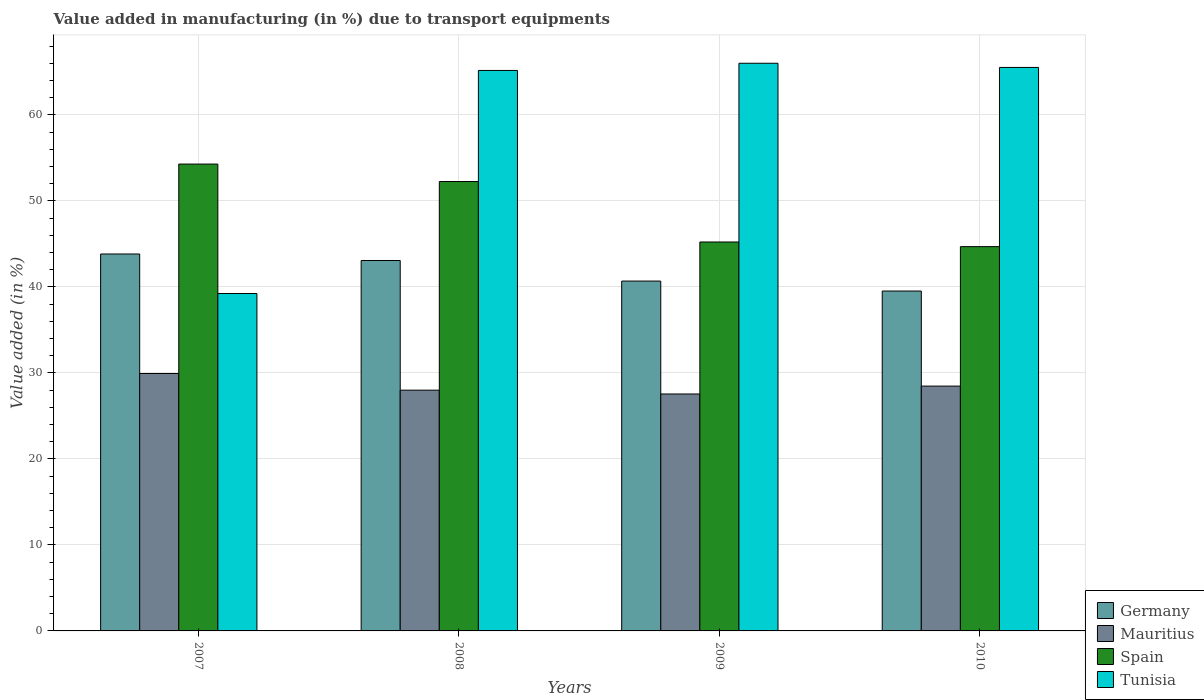How many different coloured bars are there?
Keep it short and to the point. 4. How many groups of bars are there?
Keep it short and to the point. 4. Are the number of bars per tick equal to the number of legend labels?
Your response must be concise. Yes. How many bars are there on the 3rd tick from the left?
Provide a succinct answer. 4. What is the percentage of value added in manufacturing due to transport equipments in Spain in 2009?
Provide a short and direct response. 45.22. Across all years, what is the maximum percentage of value added in manufacturing due to transport equipments in Tunisia?
Make the answer very short. 66. Across all years, what is the minimum percentage of value added in manufacturing due to transport equipments in Spain?
Your answer should be very brief. 44.68. In which year was the percentage of value added in manufacturing due to transport equipments in Mauritius maximum?
Keep it short and to the point. 2007. What is the total percentage of value added in manufacturing due to transport equipments in Mauritius in the graph?
Offer a very short reply. 113.93. What is the difference between the percentage of value added in manufacturing due to transport equipments in Germany in 2008 and that in 2009?
Make the answer very short. 2.39. What is the difference between the percentage of value added in manufacturing due to transport equipments in Tunisia in 2010 and the percentage of value added in manufacturing due to transport equipments in Mauritius in 2009?
Your answer should be very brief. 37.96. What is the average percentage of value added in manufacturing due to transport equipments in Germany per year?
Offer a terse response. 41.77. In the year 2008, what is the difference between the percentage of value added in manufacturing due to transport equipments in Germany and percentage of value added in manufacturing due to transport equipments in Mauritius?
Provide a succinct answer. 15.08. What is the ratio of the percentage of value added in manufacturing due to transport equipments in Spain in 2008 to that in 2009?
Your answer should be compact. 1.16. What is the difference between the highest and the second highest percentage of value added in manufacturing due to transport equipments in Germany?
Provide a short and direct response. 0.75. What is the difference between the highest and the lowest percentage of value added in manufacturing due to transport equipments in Spain?
Give a very brief answer. 9.6. Is it the case that in every year, the sum of the percentage of value added in manufacturing due to transport equipments in Mauritius and percentage of value added in manufacturing due to transport equipments in Tunisia is greater than the sum of percentage of value added in manufacturing due to transport equipments in Germany and percentage of value added in manufacturing due to transport equipments in Spain?
Your response must be concise. Yes. What does the 1st bar from the left in 2010 represents?
Provide a short and direct response. Germany. What does the 2nd bar from the right in 2008 represents?
Your answer should be compact. Spain. Is it the case that in every year, the sum of the percentage of value added in manufacturing due to transport equipments in Spain and percentage of value added in manufacturing due to transport equipments in Germany is greater than the percentage of value added in manufacturing due to transport equipments in Tunisia?
Your response must be concise. Yes. How many bars are there?
Provide a succinct answer. 16. How many years are there in the graph?
Provide a succinct answer. 4. What is the difference between two consecutive major ticks on the Y-axis?
Give a very brief answer. 10. Does the graph contain grids?
Provide a short and direct response. Yes. Where does the legend appear in the graph?
Ensure brevity in your answer.  Bottom right. How many legend labels are there?
Make the answer very short. 4. How are the legend labels stacked?
Provide a succinct answer. Vertical. What is the title of the graph?
Give a very brief answer. Value added in manufacturing (in %) due to transport equipments. What is the label or title of the Y-axis?
Offer a terse response. Value added (in %). What is the Value added (in %) of Germany in 2007?
Your answer should be very brief. 43.82. What is the Value added (in %) of Mauritius in 2007?
Your response must be concise. 29.93. What is the Value added (in %) of Spain in 2007?
Offer a very short reply. 54.28. What is the Value added (in %) of Tunisia in 2007?
Keep it short and to the point. 39.23. What is the Value added (in %) of Germany in 2008?
Your response must be concise. 43.07. What is the Value added (in %) in Mauritius in 2008?
Your answer should be very brief. 27.99. What is the Value added (in %) in Spain in 2008?
Ensure brevity in your answer.  52.24. What is the Value added (in %) of Tunisia in 2008?
Give a very brief answer. 65.16. What is the Value added (in %) in Germany in 2009?
Ensure brevity in your answer.  40.67. What is the Value added (in %) of Mauritius in 2009?
Your answer should be compact. 27.55. What is the Value added (in %) in Spain in 2009?
Your answer should be very brief. 45.22. What is the Value added (in %) of Tunisia in 2009?
Offer a terse response. 66. What is the Value added (in %) of Germany in 2010?
Offer a terse response. 39.51. What is the Value added (in %) of Mauritius in 2010?
Your response must be concise. 28.46. What is the Value added (in %) of Spain in 2010?
Keep it short and to the point. 44.68. What is the Value added (in %) of Tunisia in 2010?
Give a very brief answer. 65.51. Across all years, what is the maximum Value added (in %) in Germany?
Your answer should be compact. 43.82. Across all years, what is the maximum Value added (in %) of Mauritius?
Offer a terse response. 29.93. Across all years, what is the maximum Value added (in %) of Spain?
Your answer should be compact. 54.28. Across all years, what is the maximum Value added (in %) in Tunisia?
Your response must be concise. 66. Across all years, what is the minimum Value added (in %) in Germany?
Offer a terse response. 39.51. Across all years, what is the minimum Value added (in %) of Mauritius?
Make the answer very short. 27.55. Across all years, what is the minimum Value added (in %) in Spain?
Your response must be concise. 44.68. Across all years, what is the minimum Value added (in %) in Tunisia?
Provide a short and direct response. 39.23. What is the total Value added (in %) of Germany in the graph?
Keep it short and to the point. 167.08. What is the total Value added (in %) in Mauritius in the graph?
Your answer should be very brief. 113.93. What is the total Value added (in %) of Spain in the graph?
Provide a short and direct response. 196.42. What is the total Value added (in %) in Tunisia in the graph?
Offer a terse response. 235.9. What is the difference between the Value added (in %) of Germany in 2007 and that in 2008?
Make the answer very short. 0.75. What is the difference between the Value added (in %) of Mauritius in 2007 and that in 2008?
Offer a terse response. 1.94. What is the difference between the Value added (in %) of Spain in 2007 and that in 2008?
Your answer should be very brief. 2.03. What is the difference between the Value added (in %) of Tunisia in 2007 and that in 2008?
Your answer should be very brief. -25.93. What is the difference between the Value added (in %) in Germany in 2007 and that in 2009?
Offer a terse response. 3.15. What is the difference between the Value added (in %) of Mauritius in 2007 and that in 2009?
Offer a very short reply. 2.38. What is the difference between the Value added (in %) in Spain in 2007 and that in 2009?
Ensure brevity in your answer.  9.06. What is the difference between the Value added (in %) of Tunisia in 2007 and that in 2009?
Provide a short and direct response. -26.77. What is the difference between the Value added (in %) of Germany in 2007 and that in 2010?
Ensure brevity in your answer.  4.31. What is the difference between the Value added (in %) of Mauritius in 2007 and that in 2010?
Ensure brevity in your answer.  1.46. What is the difference between the Value added (in %) of Spain in 2007 and that in 2010?
Keep it short and to the point. 9.6. What is the difference between the Value added (in %) of Tunisia in 2007 and that in 2010?
Provide a succinct answer. -26.28. What is the difference between the Value added (in %) of Germany in 2008 and that in 2009?
Keep it short and to the point. 2.39. What is the difference between the Value added (in %) of Mauritius in 2008 and that in 2009?
Your response must be concise. 0.44. What is the difference between the Value added (in %) in Spain in 2008 and that in 2009?
Provide a short and direct response. 7.03. What is the difference between the Value added (in %) in Tunisia in 2008 and that in 2009?
Give a very brief answer. -0.83. What is the difference between the Value added (in %) of Germany in 2008 and that in 2010?
Offer a terse response. 3.55. What is the difference between the Value added (in %) in Mauritius in 2008 and that in 2010?
Offer a terse response. -0.47. What is the difference between the Value added (in %) in Spain in 2008 and that in 2010?
Provide a short and direct response. 7.57. What is the difference between the Value added (in %) of Tunisia in 2008 and that in 2010?
Offer a terse response. -0.35. What is the difference between the Value added (in %) of Germany in 2009 and that in 2010?
Ensure brevity in your answer.  1.16. What is the difference between the Value added (in %) in Mauritius in 2009 and that in 2010?
Your answer should be compact. -0.92. What is the difference between the Value added (in %) of Spain in 2009 and that in 2010?
Offer a very short reply. 0.54. What is the difference between the Value added (in %) of Tunisia in 2009 and that in 2010?
Provide a short and direct response. 0.49. What is the difference between the Value added (in %) of Germany in 2007 and the Value added (in %) of Mauritius in 2008?
Your response must be concise. 15.83. What is the difference between the Value added (in %) in Germany in 2007 and the Value added (in %) in Spain in 2008?
Provide a short and direct response. -8.42. What is the difference between the Value added (in %) in Germany in 2007 and the Value added (in %) in Tunisia in 2008?
Make the answer very short. -21.34. What is the difference between the Value added (in %) in Mauritius in 2007 and the Value added (in %) in Spain in 2008?
Offer a very short reply. -22.32. What is the difference between the Value added (in %) of Mauritius in 2007 and the Value added (in %) of Tunisia in 2008?
Make the answer very short. -35.24. What is the difference between the Value added (in %) in Spain in 2007 and the Value added (in %) in Tunisia in 2008?
Make the answer very short. -10.89. What is the difference between the Value added (in %) of Germany in 2007 and the Value added (in %) of Mauritius in 2009?
Your answer should be very brief. 16.27. What is the difference between the Value added (in %) in Germany in 2007 and the Value added (in %) in Spain in 2009?
Your response must be concise. -1.4. What is the difference between the Value added (in %) of Germany in 2007 and the Value added (in %) of Tunisia in 2009?
Offer a terse response. -22.18. What is the difference between the Value added (in %) in Mauritius in 2007 and the Value added (in %) in Spain in 2009?
Offer a very short reply. -15.29. What is the difference between the Value added (in %) in Mauritius in 2007 and the Value added (in %) in Tunisia in 2009?
Your answer should be very brief. -36.07. What is the difference between the Value added (in %) of Spain in 2007 and the Value added (in %) of Tunisia in 2009?
Your answer should be very brief. -11.72. What is the difference between the Value added (in %) in Germany in 2007 and the Value added (in %) in Mauritius in 2010?
Make the answer very short. 15.36. What is the difference between the Value added (in %) in Germany in 2007 and the Value added (in %) in Spain in 2010?
Your answer should be compact. -0.86. What is the difference between the Value added (in %) in Germany in 2007 and the Value added (in %) in Tunisia in 2010?
Your answer should be compact. -21.69. What is the difference between the Value added (in %) of Mauritius in 2007 and the Value added (in %) of Spain in 2010?
Make the answer very short. -14.75. What is the difference between the Value added (in %) in Mauritius in 2007 and the Value added (in %) in Tunisia in 2010?
Your answer should be compact. -35.58. What is the difference between the Value added (in %) of Spain in 2007 and the Value added (in %) of Tunisia in 2010?
Provide a succinct answer. -11.23. What is the difference between the Value added (in %) of Germany in 2008 and the Value added (in %) of Mauritius in 2009?
Your answer should be very brief. 15.52. What is the difference between the Value added (in %) in Germany in 2008 and the Value added (in %) in Spain in 2009?
Give a very brief answer. -2.15. What is the difference between the Value added (in %) of Germany in 2008 and the Value added (in %) of Tunisia in 2009?
Your answer should be very brief. -22.93. What is the difference between the Value added (in %) of Mauritius in 2008 and the Value added (in %) of Spain in 2009?
Keep it short and to the point. -17.23. What is the difference between the Value added (in %) in Mauritius in 2008 and the Value added (in %) in Tunisia in 2009?
Offer a terse response. -38.01. What is the difference between the Value added (in %) of Spain in 2008 and the Value added (in %) of Tunisia in 2009?
Offer a very short reply. -13.75. What is the difference between the Value added (in %) of Germany in 2008 and the Value added (in %) of Mauritius in 2010?
Your response must be concise. 14.6. What is the difference between the Value added (in %) in Germany in 2008 and the Value added (in %) in Spain in 2010?
Offer a very short reply. -1.61. What is the difference between the Value added (in %) in Germany in 2008 and the Value added (in %) in Tunisia in 2010?
Your answer should be very brief. -22.44. What is the difference between the Value added (in %) in Mauritius in 2008 and the Value added (in %) in Spain in 2010?
Make the answer very short. -16.69. What is the difference between the Value added (in %) in Mauritius in 2008 and the Value added (in %) in Tunisia in 2010?
Offer a very short reply. -37.52. What is the difference between the Value added (in %) of Spain in 2008 and the Value added (in %) of Tunisia in 2010?
Ensure brevity in your answer.  -13.27. What is the difference between the Value added (in %) in Germany in 2009 and the Value added (in %) in Mauritius in 2010?
Your answer should be compact. 12.21. What is the difference between the Value added (in %) of Germany in 2009 and the Value added (in %) of Spain in 2010?
Your answer should be compact. -4. What is the difference between the Value added (in %) in Germany in 2009 and the Value added (in %) in Tunisia in 2010?
Your answer should be compact. -24.84. What is the difference between the Value added (in %) in Mauritius in 2009 and the Value added (in %) in Spain in 2010?
Your answer should be compact. -17.13. What is the difference between the Value added (in %) in Mauritius in 2009 and the Value added (in %) in Tunisia in 2010?
Provide a succinct answer. -37.96. What is the difference between the Value added (in %) in Spain in 2009 and the Value added (in %) in Tunisia in 2010?
Offer a terse response. -20.29. What is the average Value added (in %) in Germany per year?
Your answer should be very brief. 41.77. What is the average Value added (in %) of Mauritius per year?
Your response must be concise. 28.48. What is the average Value added (in %) in Spain per year?
Give a very brief answer. 49.1. What is the average Value added (in %) of Tunisia per year?
Provide a succinct answer. 58.97. In the year 2007, what is the difference between the Value added (in %) in Germany and Value added (in %) in Mauritius?
Your answer should be compact. 13.89. In the year 2007, what is the difference between the Value added (in %) of Germany and Value added (in %) of Spain?
Keep it short and to the point. -10.46. In the year 2007, what is the difference between the Value added (in %) in Germany and Value added (in %) in Tunisia?
Your answer should be compact. 4.59. In the year 2007, what is the difference between the Value added (in %) of Mauritius and Value added (in %) of Spain?
Provide a succinct answer. -24.35. In the year 2007, what is the difference between the Value added (in %) of Mauritius and Value added (in %) of Tunisia?
Ensure brevity in your answer.  -9.3. In the year 2007, what is the difference between the Value added (in %) in Spain and Value added (in %) in Tunisia?
Keep it short and to the point. 15.05. In the year 2008, what is the difference between the Value added (in %) of Germany and Value added (in %) of Mauritius?
Offer a very short reply. 15.08. In the year 2008, what is the difference between the Value added (in %) in Germany and Value added (in %) in Spain?
Make the answer very short. -9.18. In the year 2008, what is the difference between the Value added (in %) in Germany and Value added (in %) in Tunisia?
Provide a short and direct response. -22.1. In the year 2008, what is the difference between the Value added (in %) in Mauritius and Value added (in %) in Spain?
Keep it short and to the point. -24.25. In the year 2008, what is the difference between the Value added (in %) in Mauritius and Value added (in %) in Tunisia?
Give a very brief answer. -37.17. In the year 2008, what is the difference between the Value added (in %) in Spain and Value added (in %) in Tunisia?
Give a very brief answer. -12.92. In the year 2009, what is the difference between the Value added (in %) in Germany and Value added (in %) in Mauritius?
Provide a succinct answer. 13.13. In the year 2009, what is the difference between the Value added (in %) in Germany and Value added (in %) in Spain?
Offer a terse response. -4.54. In the year 2009, what is the difference between the Value added (in %) in Germany and Value added (in %) in Tunisia?
Keep it short and to the point. -25.32. In the year 2009, what is the difference between the Value added (in %) of Mauritius and Value added (in %) of Spain?
Offer a very short reply. -17.67. In the year 2009, what is the difference between the Value added (in %) in Mauritius and Value added (in %) in Tunisia?
Make the answer very short. -38.45. In the year 2009, what is the difference between the Value added (in %) of Spain and Value added (in %) of Tunisia?
Keep it short and to the point. -20.78. In the year 2010, what is the difference between the Value added (in %) in Germany and Value added (in %) in Mauritius?
Give a very brief answer. 11.05. In the year 2010, what is the difference between the Value added (in %) of Germany and Value added (in %) of Spain?
Your response must be concise. -5.16. In the year 2010, what is the difference between the Value added (in %) in Germany and Value added (in %) in Tunisia?
Give a very brief answer. -26. In the year 2010, what is the difference between the Value added (in %) in Mauritius and Value added (in %) in Spain?
Provide a short and direct response. -16.22. In the year 2010, what is the difference between the Value added (in %) in Mauritius and Value added (in %) in Tunisia?
Your answer should be compact. -37.05. In the year 2010, what is the difference between the Value added (in %) in Spain and Value added (in %) in Tunisia?
Your answer should be compact. -20.83. What is the ratio of the Value added (in %) of Germany in 2007 to that in 2008?
Your response must be concise. 1.02. What is the ratio of the Value added (in %) in Mauritius in 2007 to that in 2008?
Your answer should be very brief. 1.07. What is the ratio of the Value added (in %) in Spain in 2007 to that in 2008?
Your answer should be very brief. 1.04. What is the ratio of the Value added (in %) in Tunisia in 2007 to that in 2008?
Your response must be concise. 0.6. What is the ratio of the Value added (in %) in Germany in 2007 to that in 2009?
Ensure brevity in your answer.  1.08. What is the ratio of the Value added (in %) of Mauritius in 2007 to that in 2009?
Your answer should be very brief. 1.09. What is the ratio of the Value added (in %) of Spain in 2007 to that in 2009?
Keep it short and to the point. 1.2. What is the ratio of the Value added (in %) of Tunisia in 2007 to that in 2009?
Offer a terse response. 0.59. What is the ratio of the Value added (in %) of Germany in 2007 to that in 2010?
Your answer should be very brief. 1.11. What is the ratio of the Value added (in %) in Mauritius in 2007 to that in 2010?
Keep it short and to the point. 1.05. What is the ratio of the Value added (in %) of Spain in 2007 to that in 2010?
Your answer should be very brief. 1.21. What is the ratio of the Value added (in %) in Tunisia in 2007 to that in 2010?
Your answer should be very brief. 0.6. What is the ratio of the Value added (in %) of Germany in 2008 to that in 2009?
Your answer should be compact. 1.06. What is the ratio of the Value added (in %) in Mauritius in 2008 to that in 2009?
Keep it short and to the point. 1.02. What is the ratio of the Value added (in %) of Spain in 2008 to that in 2009?
Your response must be concise. 1.16. What is the ratio of the Value added (in %) of Tunisia in 2008 to that in 2009?
Keep it short and to the point. 0.99. What is the ratio of the Value added (in %) in Germany in 2008 to that in 2010?
Your answer should be compact. 1.09. What is the ratio of the Value added (in %) of Mauritius in 2008 to that in 2010?
Provide a short and direct response. 0.98. What is the ratio of the Value added (in %) of Spain in 2008 to that in 2010?
Your answer should be very brief. 1.17. What is the ratio of the Value added (in %) in Tunisia in 2008 to that in 2010?
Offer a terse response. 0.99. What is the ratio of the Value added (in %) in Germany in 2009 to that in 2010?
Offer a very short reply. 1.03. What is the ratio of the Value added (in %) in Mauritius in 2009 to that in 2010?
Your response must be concise. 0.97. What is the ratio of the Value added (in %) of Spain in 2009 to that in 2010?
Provide a succinct answer. 1.01. What is the ratio of the Value added (in %) of Tunisia in 2009 to that in 2010?
Make the answer very short. 1.01. What is the difference between the highest and the second highest Value added (in %) in Germany?
Your answer should be very brief. 0.75. What is the difference between the highest and the second highest Value added (in %) of Mauritius?
Your answer should be compact. 1.46. What is the difference between the highest and the second highest Value added (in %) in Spain?
Give a very brief answer. 2.03. What is the difference between the highest and the second highest Value added (in %) in Tunisia?
Provide a short and direct response. 0.49. What is the difference between the highest and the lowest Value added (in %) in Germany?
Ensure brevity in your answer.  4.31. What is the difference between the highest and the lowest Value added (in %) in Mauritius?
Offer a very short reply. 2.38. What is the difference between the highest and the lowest Value added (in %) of Spain?
Keep it short and to the point. 9.6. What is the difference between the highest and the lowest Value added (in %) in Tunisia?
Your response must be concise. 26.77. 